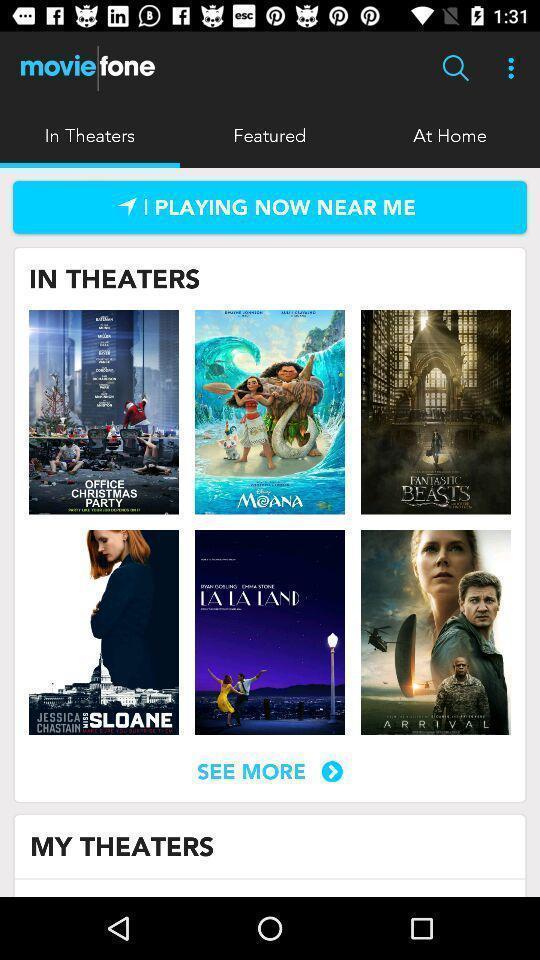Describe the key features of this screenshot. Page showing multiple movies in a booking app. 